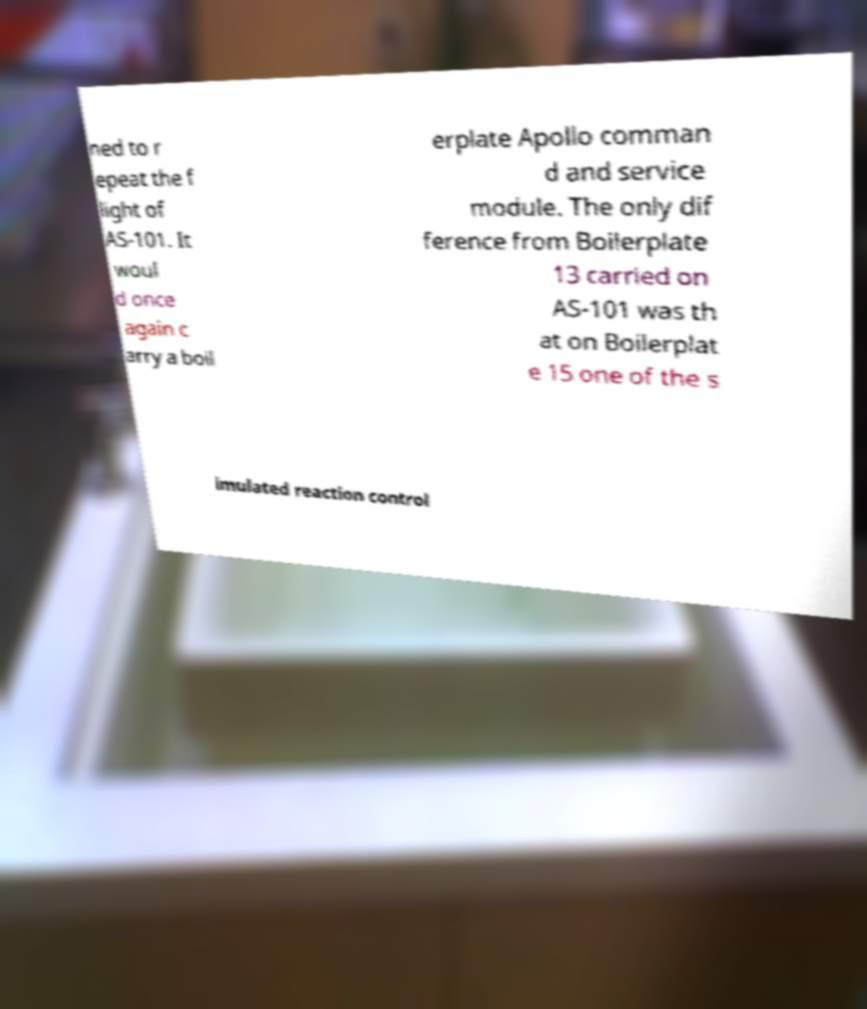Could you assist in decoding the text presented in this image and type it out clearly? ned to r epeat the f light of AS-101. It woul d once again c arry a boil erplate Apollo comman d and service module. The only dif ference from Boilerplate 13 carried on AS-101 was th at on Boilerplat e 15 one of the s imulated reaction control 